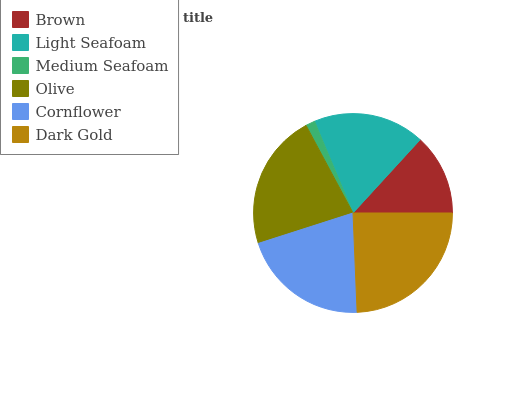Is Medium Seafoam the minimum?
Answer yes or no. Yes. Is Dark Gold the maximum?
Answer yes or no. Yes. Is Light Seafoam the minimum?
Answer yes or no. No. Is Light Seafoam the maximum?
Answer yes or no. No. Is Light Seafoam greater than Brown?
Answer yes or no. Yes. Is Brown less than Light Seafoam?
Answer yes or no. Yes. Is Brown greater than Light Seafoam?
Answer yes or no. No. Is Light Seafoam less than Brown?
Answer yes or no. No. Is Cornflower the high median?
Answer yes or no. Yes. Is Light Seafoam the low median?
Answer yes or no. Yes. Is Brown the high median?
Answer yes or no. No. Is Brown the low median?
Answer yes or no. No. 